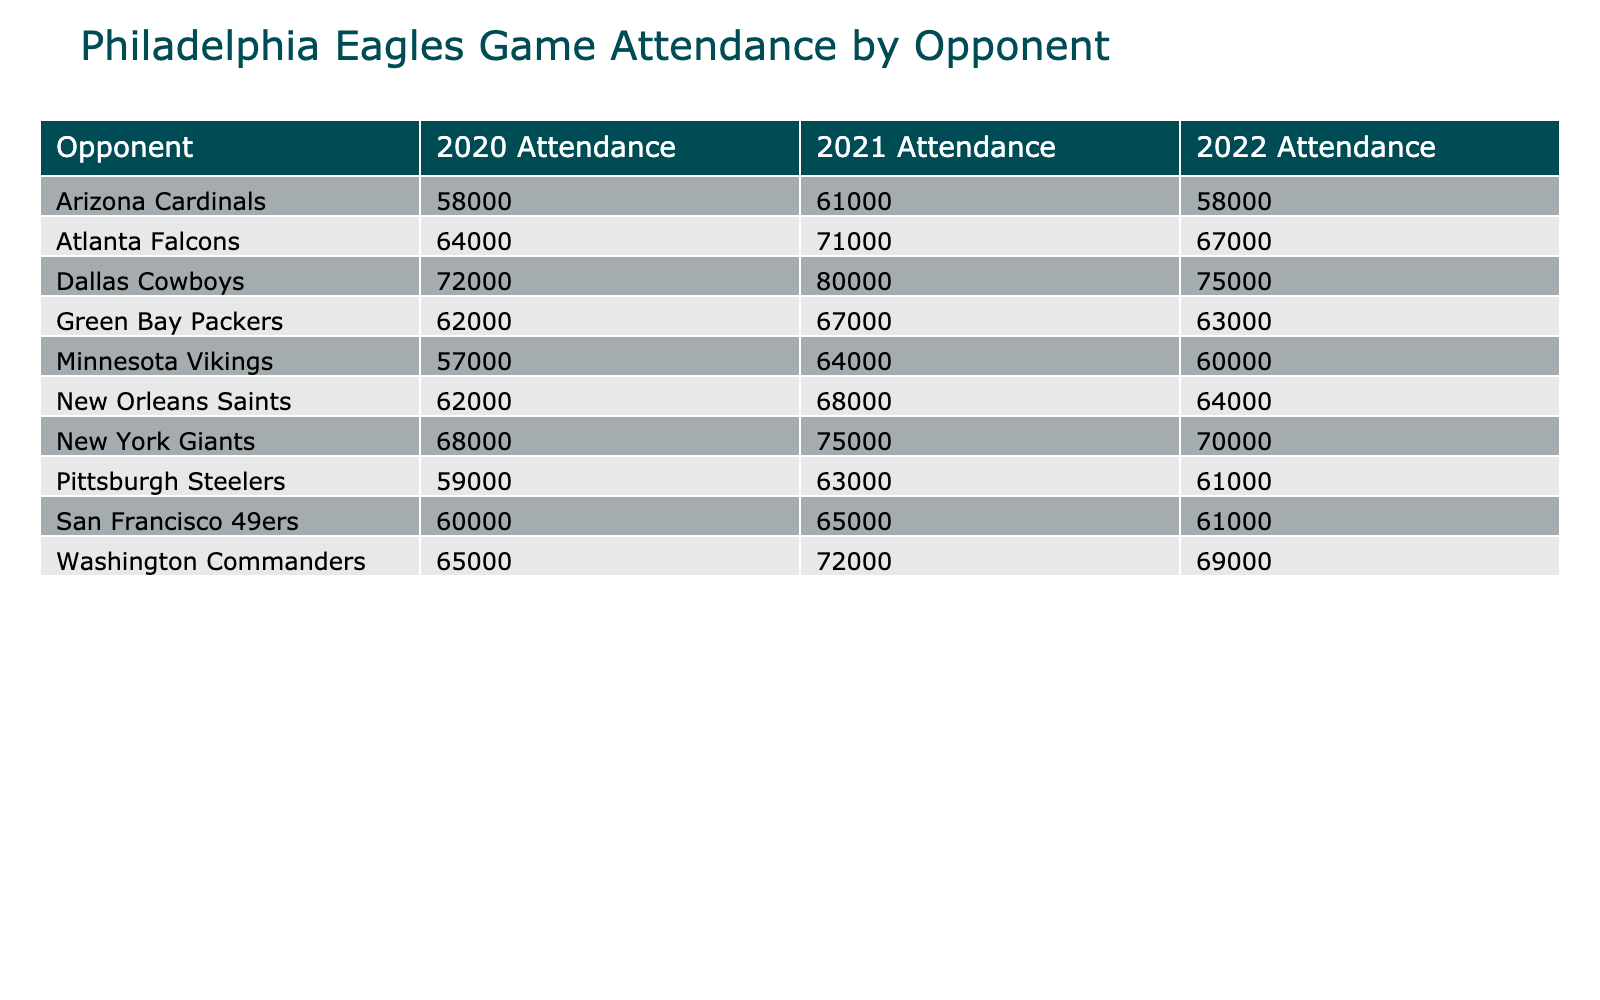What was the attendance for the Eagles game against the Dallas Cowboys in 2021? The table shows the attendance for each opponent in each season. For the Dallas Cowboys in 2021, the attendance is directly listed as 80,000.
Answer: 80,000 Which opponent had the highest attendance in 2020? By checking the attendance figures for each opponent in 2020, the highest attendance is for the Dallas Cowboys with 72,000.
Answer: Dallas Cowboys What is the average attendance for the Philadelphia Eagles games against the New York Giants from 2020 to 2022? To find the average, we need to add the attendance for the New York Giants for all three seasons: (68,000 + 75,000 + 70,000) = 213,000. Next, we divide that by the number of seasons, which is 3: 213,000 / 3 = 71,000.
Answer: 71,000 Did the attendance against the Green Bay Packers increase from 2020 to 2021? The attendance for the Green Bay Packers in 2020 was 62,000, and in 2021 it was 67,000. Since 67,000 > 62,000, the attendance did increase.
Answer: Yes Which opponent had the lowest attendance in 2022 and how much was it? Looking at the 2022 attendance figures, the Arizona Cardinals had the lowest attendance at 58,000.
Answer: Arizona Cardinals, 58,000 What was the change in attendance from 2021 to 2022 for the San Francisco 49ers? For the San Francisco 49ers, we take the attendance from 2021, which is 65,000, and subtract the 2022 attendance of 61,000. The change is 65,000 - 61,000 = 4,000. Thus, attendance decreased by 4,000.
Answer: Decrease of 4,000 How many opponents had attendance figures exceeding 70,000 in 2021? In 2021, checking the attendance figures, the opponents with attendance over 70,000 are the Dallas Cowboys (80,000), New York Giants (75,000), and Atlanta Falcons (71,000). That gives us a total of 3 opponents.
Answer: 3 Was the attendance for the New Orleans Saints higher in 2021 than in 2020? The attendance for the New Orleans Saints in 2020 was 62,000 and in 2021 was 68,000. Since 68,000 > 62,000, the attendance was higher in 2021.
Answer: Yes What was the overall trend in attendance for the Philadelphia Eagles games against the Washington Commanders from 2020 to 2022? The attendance against the Washington Commanders went from 65,000 in 2020 to 72,000 in 2021 (an increase), but then dropped to 69,000 in 2022 (a decrease). Overall, there was an increase from 2020 to 2021 followed by a decrease in 2022, showing a fluctuating trend.
Answer: Fluctuating trend 